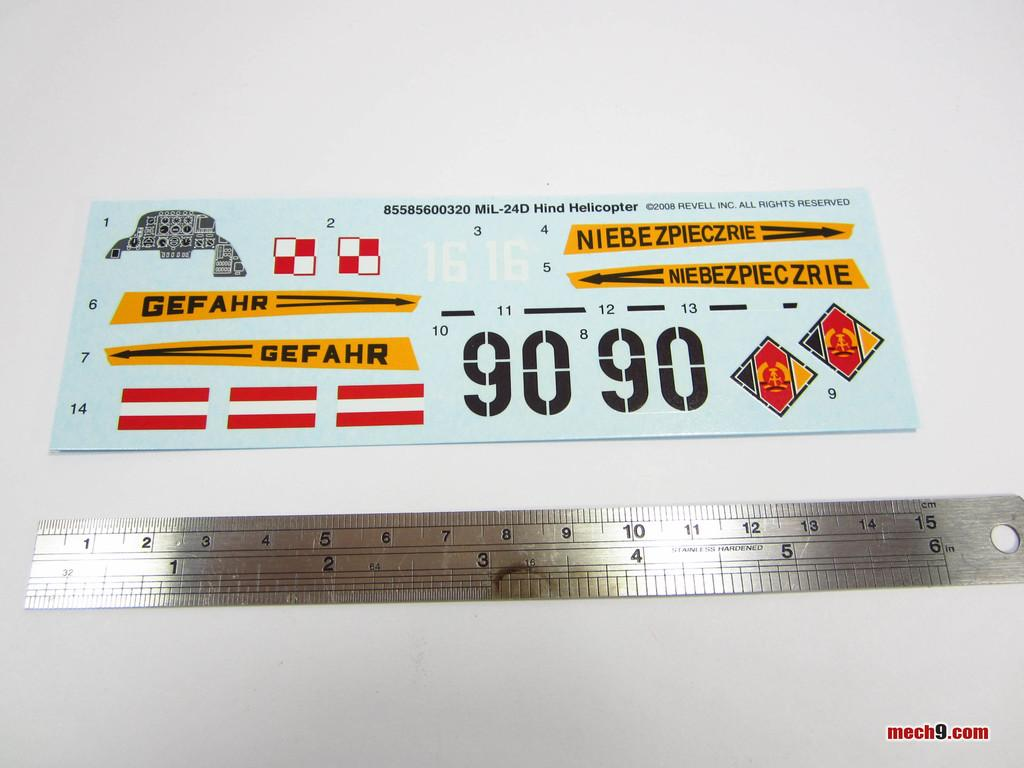<image>
Write a terse but informative summary of the picture. A ruler with a sign above that reads Gefahr. 